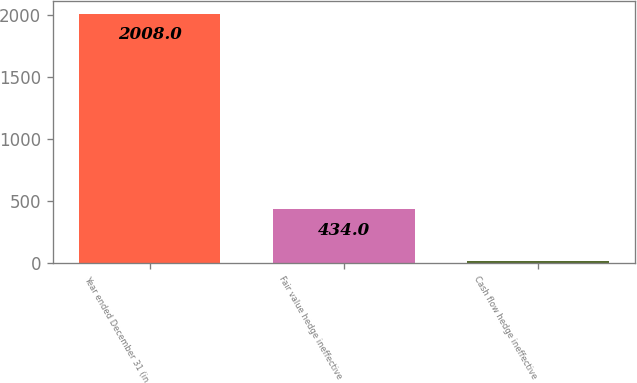Convert chart to OTSL. <chart><loc_0><loc_0><loc_500><loc_500><bar_chart><fcel>Year ended December 31 (in<fcel>Fair value hedge ineffective<fcel>Cash flow hedge ineffective<nl><fcel>2008<fcel>434<fcel>18<nl></chart> 